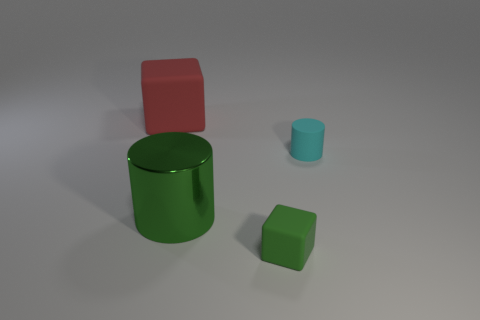What number of other objects are there of the same shape as the red rubber thing?
Give a very brief answer. 1. Is the large metallic object the same shape as the small green thing?
Keep it short and to the point. No. The matte object that is on the left side of the tiny cyan rubber cylinder and behind the green shiny cylinder is what color?
Offer a very short reply. Red. There is another object that is the same color as the metallic object; what size is it?
Your answer should be very brief. Small. How many tiny things are metallic cylinders or red matte cubes?
Make the answer very short. 0. Is there anything else that has the same color as the large block?
Make the answer very short. No. There is a cylinder on the right side of the matte block in front of the matte object on the left side of the green cylinder; what is its material?
Provide a short and direct response. Rubber. What number of shiny objects are cylinders or cubes?
Your response must be concise. 1. What number of brown things are either matte things or tiny metallic cylinders?
Your answer should be very brief. 0. There is a large thing that is in front of the red rubber thing; does it have the same color as the tiny cylinder?
Make the answer very short. No. 